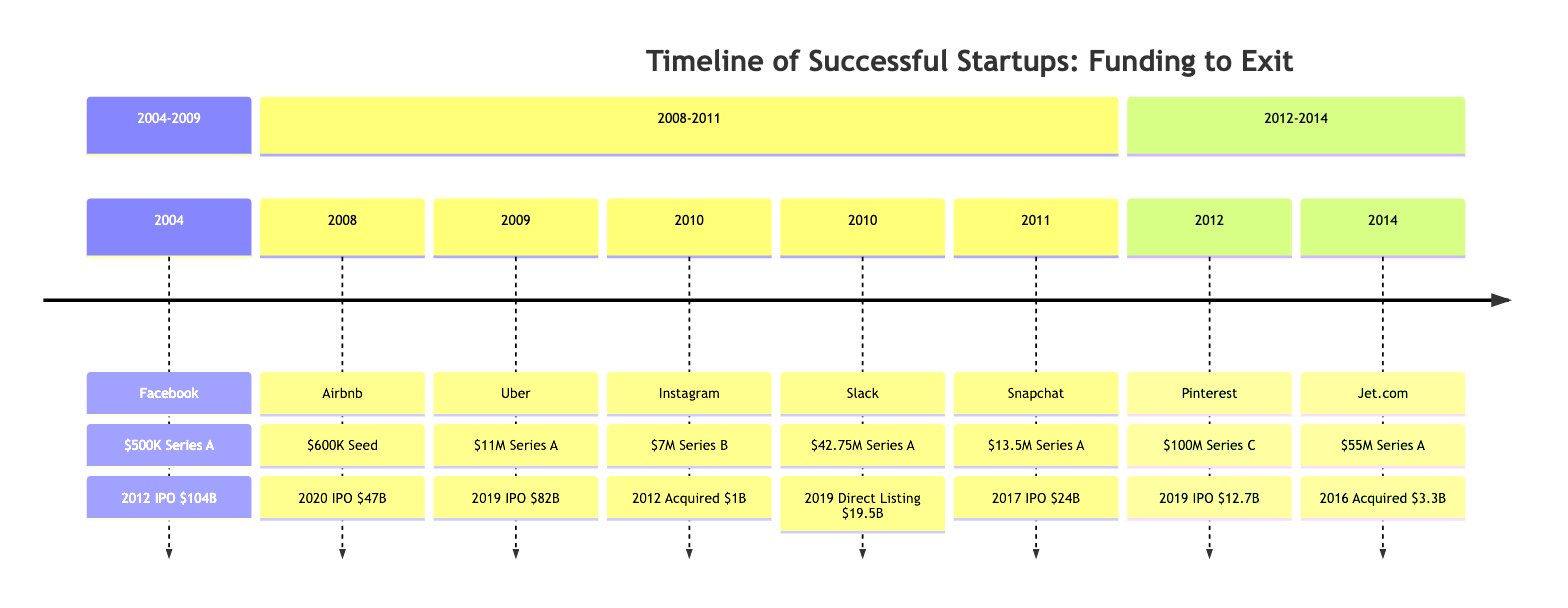What year did Facebook exit? The diagram indicates that Facebook, which was funded in 2004, had its exit strategy realized through an IPO in 2012.
Answer: 2012 Which investor backed Instagram? According to the timeline, Instagram was funded by Benchmark Capital in its Series B round in 2010.
Answer: Benchmark Capital What was the exit value of Jet.com? The exit strategy of Jet.com, which was acquired by Walmart in 2016, had an exit value of $3.3 billion according to the diagram.
Answer: $3.3 billion How much funding did Snapchat receive? The timeline records that Snapchat received $13.5 million in its Series A funding round in 2011.
Answer: $13.5 million What is the exit strategy for Airbnb? The diagram shows Airbnb's exit strategy was an IPO, which occurred in 2020 after its initial funding in 2008.
Answer: IPO Which startup had the highest exit value? By analyzing the diagram, Facebook's IPO exit in 2012 had the highest exit value at $104 billion, compared to other startups listed.
Answer: $104 billion How many startups had IPO exits between 2004 and 2014? The diagram lists four startups (Facebook, Airbnb, Uber, and Snapchat) that had IPO exits during this time period.
Answer: 4 Which startup was acquired by Facebook? The timeline specifies that Instagram was acquired by Facebook in 2012 after its Series B funding round.
Answer: Instagram What year did Slack go public? The diagram states that Slack went public through a direct listing in 2019, following its Series A funding in 2010.
Answer: 2019 